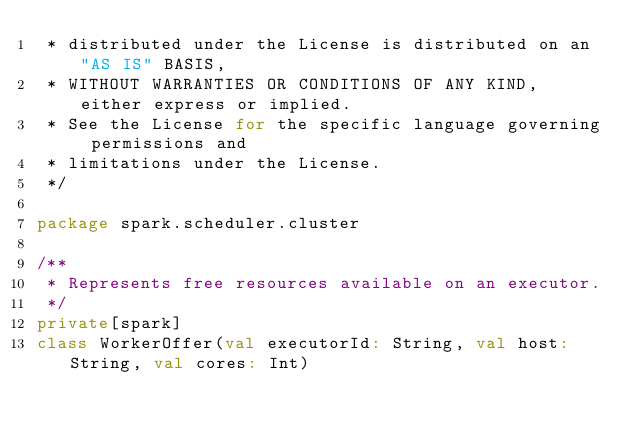<code> <loc_0><loc_0><loc_500><loc_500><_Scala_> * distributed under the License is distributed on an "AS IS" BASIS,
 * WITHOUT WARRANTIES OR CONDITIONS OF ANY KIND, either express or implied.
 * See the License for the specific language governing permissions and
 * limitations under the License.
 */

package spark.scheduler.cluster

/**
 * Represents free resources available on an executor.
 */
private[spark]
class WorkerOffer(val executorId: String, val host: String, val cores: Int)
</code> 